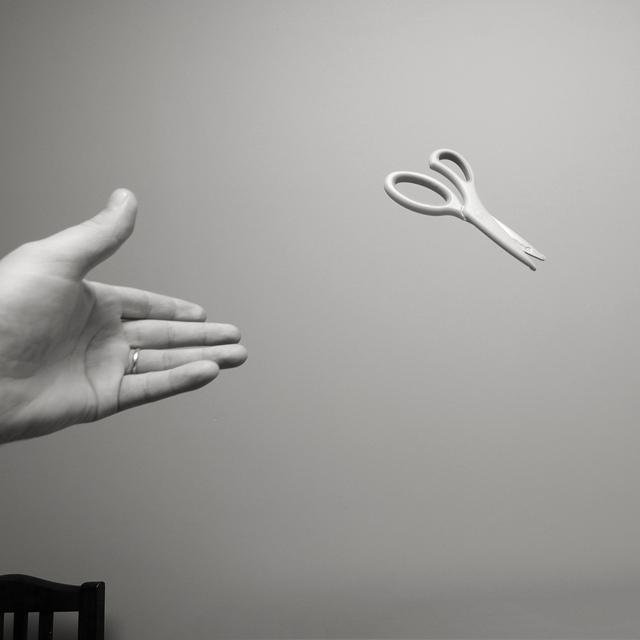How will the scissors move next? down 